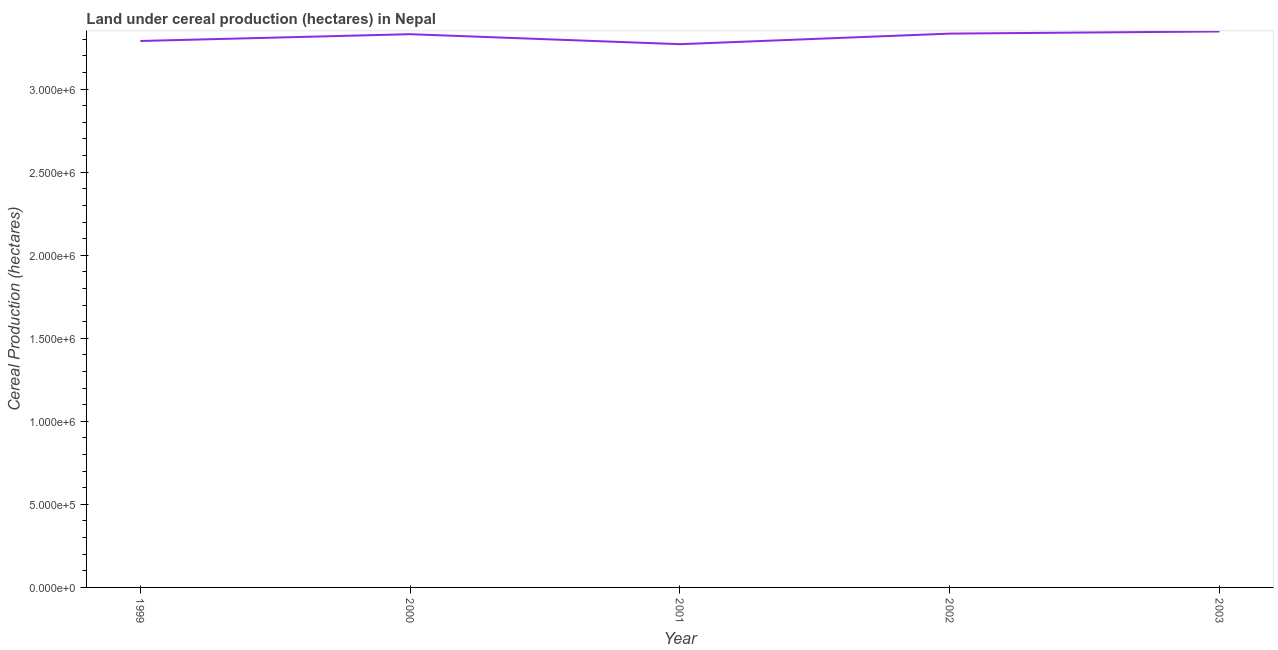What is the land under cereal production in 2000?
Provide a succinct answer. 3.33e+06. Across all years, what is the maximum land under cereal production?
Offer a terse response. 3.35e+06. Across all years, what is the minimum land under cereal production?
Offer a terse response. 3.27e+06. In which year was the land under cereal production maximum?
Offer a terse response. 2003. In which year was the land under cereal production minimum?
Offer a terse response. 2001. What is the sum of the land under cereal production?
Your answer should be compact. 1.66e+07. What is the difference between the land under cereal production in 2001 and 2003?
Ensure brevity in your answer.  -7.66e+04. What is the average land under cereal production per year?
Offer a very short reply. 3.31e+06. What is the median land under cereal production?
Your answer should be compact. 3.33e+06. Do a majority of the years between 2003 and 2002 (inclusive) have land under cereal production greater than 2200000 hectares?
Your answer should be compact. No. What is the ratio of the land under cereal production in 1999 to that in 2003?
Keep it short and to the point. 0.98. Is the difference between the land under cereal production in 1999 and 2002 greater than the difference between any two years?
Ensure brevity in your answer.  No. What is the difference between the highest and the second highest land under cereal production?
Provide a succinct answer. 1.29e+04. Is the sum of the land under cereal production in 1999 and 2003 greater than the maximum land under cereal production across all years?
Your response must be concise. Yes. What is the difference between the highest and the lowest land under cereal production?
Give a very brief answer. 7.66e+04. In how many years, is the land under cereal production greater than the average land under cereal production taken over all years?
Your answer should be very brief. 3. Does the land under cereal production monotonically increase over the years?
Your answer should be compact. No. How many lines are there?
Your answer should be very brief. 1. How many years are there in the graph?
Provide a short and direct response. 5. Does the graph contain any zero values?
Offer a terse response. No. What is the title of the graph?
Ensure brevity in your answer.  Land under cereal production (hectares) in Nepal. What is the label or title of the Y-axis?
Give a very brief answer. Cereal Production (hectares). What is the Cereal Production (hectares) in 1999?
Provide a succinct answer. 3.29e+06. What is the Cereal Production (hectares) of 2000?
Make the answer very short. 3.33e+06. What is the Cereal Production (hectares) in 2001?
Your response must be concise. 3.27e+06. What is the Cereal Production (hectares) in 2002?
Give a very brief answer. 3.33e+06. What is the Cereal Production (hectares) in 2003?
Keep it short and to the point. 3.35e+06. What is the difference between the Cereal Production (hectares) in 1999 and 2000?
Give a very brief answer. -4.09e+04. What is the difference between the Cereal Production (hectares) in 1999 and 2001?
Provide a succinct answer. 1.93e+04. What is the difference between the Cereal Production (hectares) in 1999 and 2002?
Offer a very short reply. -4.44e+04. What is the difference between the Cereal Production (hectares) in 1999 and 2003?
Your answer should be very brief. -5.73e+04. What is the difference between the Cereal Production (hectares) in 2000 and 2001?
Your answer should be very brief. 6.01e+04. What is the difference between the Cereal Production (hectares) in 2000 and 2002?
Give a very brief answer. -3519. What is the difference between the Cereal Production (hectares) in 2000 and 2003?
Your answer should be compact. -1.65e+04. What is the difference between the Cereal Production (hectares) in 2001 and 2002?
Make the answer very short. -6.36e+04. What is the difference between the Cereal Production (hectares) in 2001 and 2003?
Your answer should be very brief. -7.66e+04. What is the difference between the Cereal Production (hectares) in 2002 and 2003?
Your answer should be very brief. -1.29e+04. What is the ratio of the Cereal Production (hectares) in 1999 to that in 2001?
Your answer should be very brief. 1.01. What is the ratio of the Cereal Production (hectares) in 2000 to that in 2003?
Provide a succinct answer. 0.99. What is the ratio of the Cereal Production (hectares) in 2001 to that in 2002?
Offer a terse response. 0.98. 